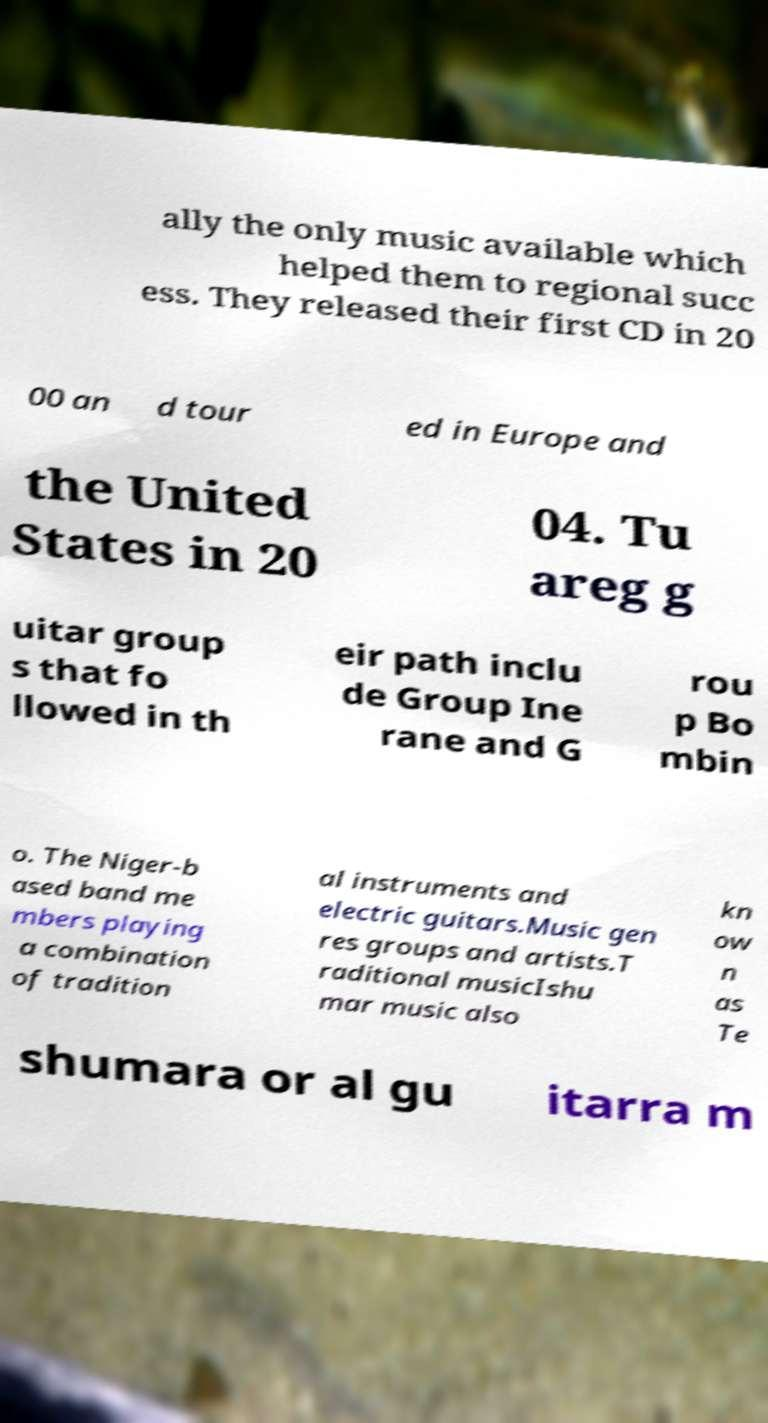I need the written content from this picture converted into text. Can you do that? ally the only music available which helped them to regional succ ess. They released their first CD in 20 00 an d tour ed in Europe and the United States in 20 04. Tu areg g uitar group s that fo llowed in th eir path inclu de Group Ine rane and G rou p Bo mbin o. The Niger-b ased band me mbers playing a combination of tradition al instruments and electric guitars.Music gen res groups and artists.T raditional musicIshu mar music also kn ow n as Te shumara or al gu itarra m 